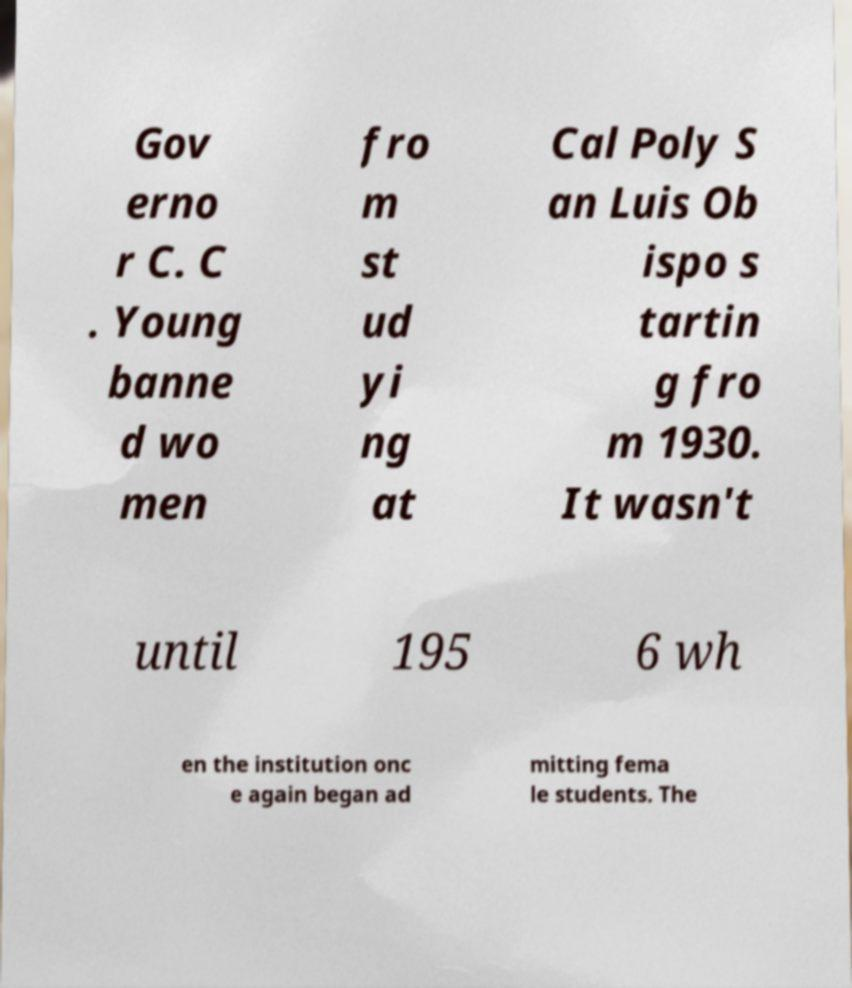For documentation purposes, I need the text within this image transcribed. Could you provide that? Gov erno r C. C . Young banne d wo men fro m st ud yi ng at Cal Poly S an Luis Ob ispo s tartin g fro m 1930. It wasn't until 195 6 wh en the institution onc e again began ad mitting fema le students. The 